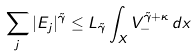Convert formula to latex. <formula><loc_0><loc_0><loc_500><loc_500>\sum _ { j } | E _ { j } | ^ { \tilde { \gamma } } \leq L _ { \tilde { \gamma } } \int _ { X } V _ { - } ^ { \tilde { \gamma } + \kappa } \, d x</formula> 